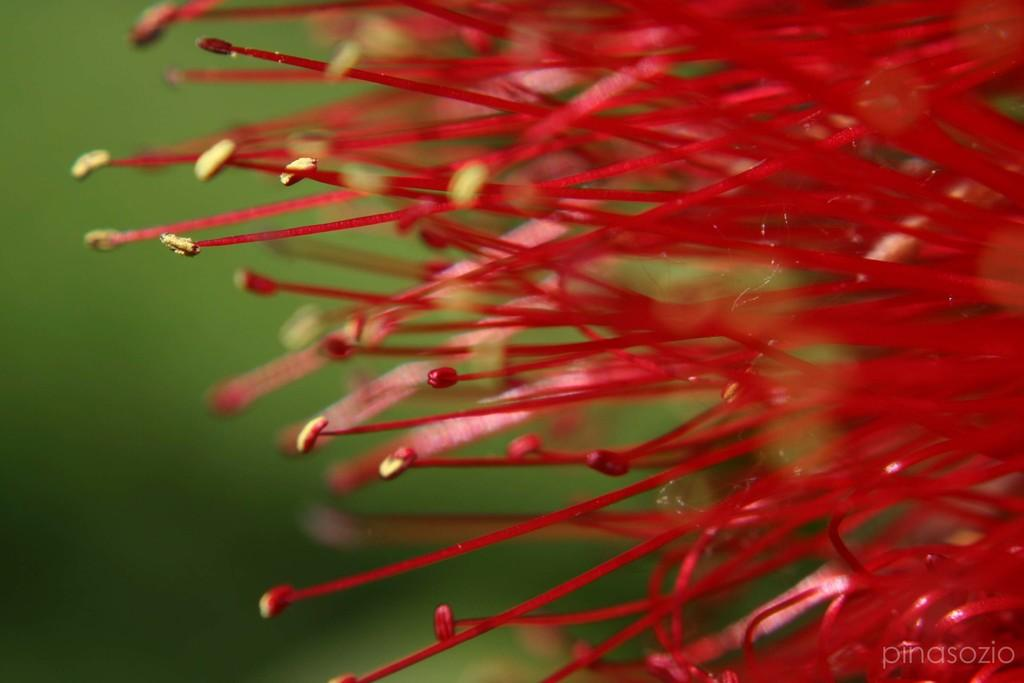What color are the stamens in the image? The stamens in the image are red. What color is the background of the image? The background of the image is green and blurred. Is there any text or logo visible in the image? Yes, there is a watermark in the right corner of the image. How many beds can be seen in the image? There are no beds present in the image. Is there a woman interacting with the stamens in the image? There is no woman present in the image. 